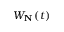Convert formula to latex. <formula><loc_0><loc_0><loc_500><loc_500>W _ { N } \left ( t \right )</formula> 